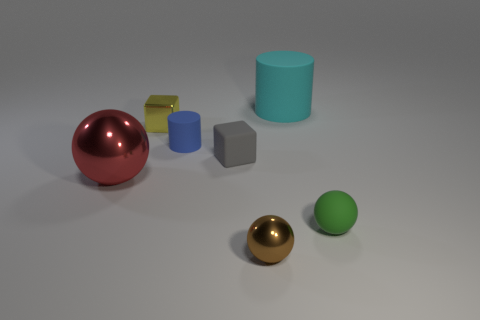Does the green object have the same shape as the large red shiny thing?
Your response must be concise. Yes. How many tiny objects are either yellow shiny things or blue cylinders?
Offer a very short reply. 2. What color is the small shiny sphere?
Offer a terse response. Brown. What shape is the rubber object in front of the large object in front of the matte cube?
Offer a terse response. Sphere. Are there any big objects made of the same material as the small gray object?
Your response must be concise. Yes. Does the rubber cylinder that is to the right of the rubber cube have the same size as the red metal ball?
Provide a short and direct response. Yes. How many blue objects are either blocks or big things?
Ensure brevity in your answer.  0. There is a cylinder that is behind the yellow thing; what is its material?
Make the answer very short. Rubber. How many big metallic balls are to the left of the shiny ball on the left side of the brown thing?
Ensure brevity in your answer.  0. How many cyan matte things are the same shape as the tiny blue thing?
Provide a short and direct response. 1. 